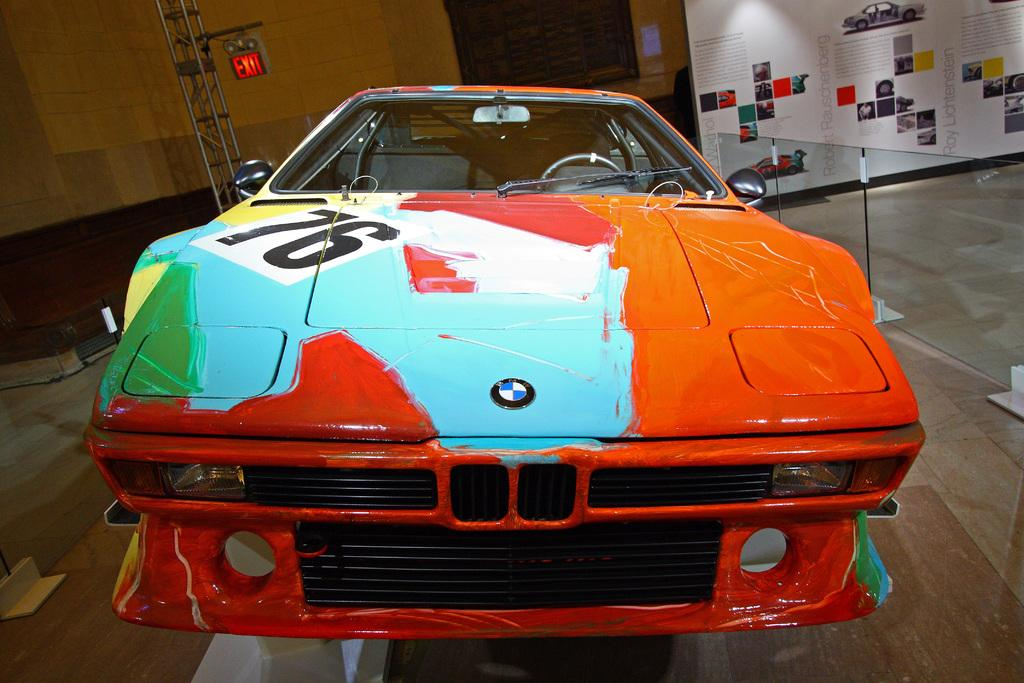What type of vehicle is featured in the image? There is a painted car in the image. How is the car positioned in the image? The car is on a stand in the image. What else can be seen in the image besides the car? There are posters and a fence in the image. Can you tell me how many hairs are being cut on the car in the image? There is no haircut taking place on the car in the image; it is a painted car on a stand. What type of cloud can be seen in the image? There is no cloud present in the image. 